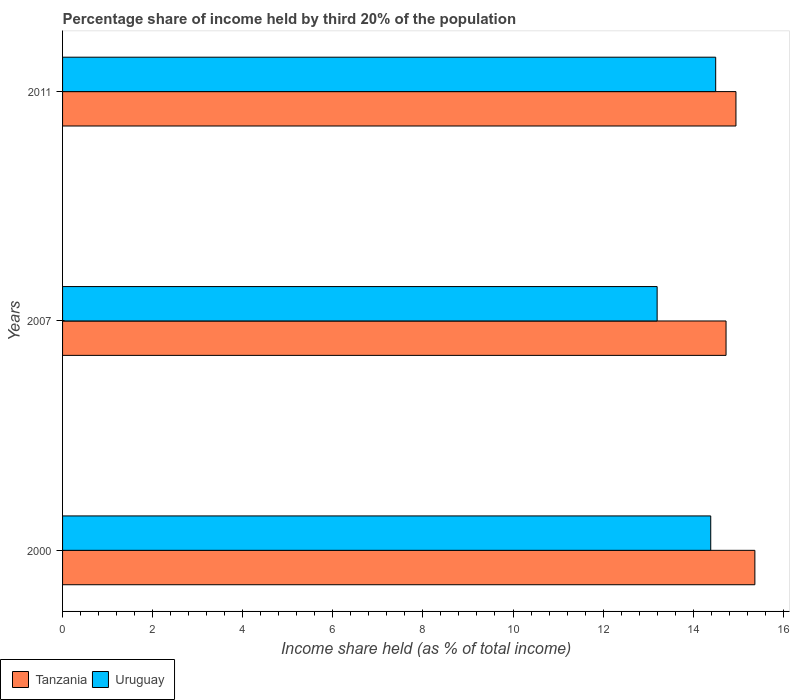How many different coloured bars are there?
Make the answer very short. 2. Are the number of bars per tick equal to the number of legend labels?
Your answer should be very brief. Yes. In how many cases, is the number of bars for a given year not equal to the number of legend labels?
Make the answer very short. 0. Across all years, what is the maximum share of income held by third 20% of the population in Uruguay?
Ensure brevity in your answer.  14.5. Across all years, what is the minimum share of income held by third 20% of the population in Tanzania?
Give a very brief answer. 14.73. In which year was the share of income held by third 20% of the population in Tanzania minimum?
Make the answer very short. 2007. What is the total share of income held by third 20% of the population in Uruguay in the graph?
Your response must be concise. 42.09. What is the difference between the share of income held by third 20% of the population in Uruguay in 2007 and that in 2011?
Make the answer very short. -1.3. What is the difference between the share of income held by third 20% of the population in Tanzania in 2000 and the share of income held by third 20% of the population in Uruguay in 2011?
Your answer should be compact. 0.87. What is the average share of income held by third 20% of the population in Tanzania per year?
Your answer should be compact. 15.02. In the year 2011, what is the difference between the share of income held by third 20% of the population in Uruguay and share of income held by third 20% of the population in Tanzania?
Your answer should be compact. -0.45. What is the ratio of the share of income held by third 20% of the population in Uruguay in 2000 to that in 2011?
Your answer should be very brief. 0.99. What is the difference between the highest and the second highest share of income held by third 20% of the population in Tanzania?
Your response must be concise. 0.42. What is the difference between the highest and the lowest share of income held by third 20% of the population in Uruguay?
Provide a short and direct response. 1.3. Is the sum of the share of income held by third 20% of the population in Uruguay in 2000 and 2007 greater than the maximum share of income held by third 20% of the population in Tanzania across all years?
Offer a terse response. Yes. What does the 2nd bar from the top in 2007 represents?
Provide a succinct answer. Tanzania. What does the 1st bar from the bottom in 2007 represents?
Give a very brief answer. Tanzania. How many bars are there?
Provide a short and direct response. 6. Are all the bars in the graph horizontal?
Offer a terse response. Yes. What is the difference between two consecutive major ticks on the X-axis?
Your answer should be very brief. 2. Are the values on the major ticks of X-axis written in scientific E-notation?
Your response must be concise. No. Does the graph contain any zero values?
Your response must be concise. No. Does the graph contain grids?
Your answer should be compact. No. How many legend labels are there?
Your response must be concise. 2. How are the legend labels stacked?
Your answer should be very brief. Horizontal. What is the title of the graph?
Your answer should be compact. Percentage share of income held by third 20% of the population. What is the label or title of the X-axis?
Ensure brevity in your answer.  Income share held (as % of total income). What is the Income share held (as % of total income) in Tanzania in 2000?
Provide a succinct answer. 15.37. What is the Income share held (as % of total income) in Uruguay in 2000?
Offer a terse response. 14.39. What is the Income share held (as % of total income) in Tanzania in 2007?
Give a very brief answer. 14.73. What is the Income share held (as % of total income) of Tanzania in 2011?
Offer a very short reply. 14.95. What is the Income share held (as % of total income) in Uruguay in 2011?
Your answer should be very brief. 14.5. Across all years, what is the maximum Income share held (as % of total income) in Tanzania?
Offer a terse response. 15.37. Across all years, what is the maximum Income share held (as % of total income) of Uruguay?
Provide a succinct answer. 14.5. Across all years, what is the minimum Income share held (as % of total income) in Tanzania?
Offer a terse response. 14.73. Across all years, what is the minimum Income share held (as % of total income) in Uruguay?
Keep it short and to the point. 13.2. What is the total Income share held (as % of total income) of Tanzania in the graph?
Keep it short and to the point. 45.05. What is the total Income share held (as % of total income) in Uruguay in the graph?
Provide a short and direct response. 42.09. What is the difference between the Income share held (as % of total income) of Tanzania in 2000 and that in 2007?
Make the answer very short. 0.64. What is the difference between the Income share held (as % of total income) in Uruguay in 2000 and that in 2007?
Your answer should be compact. 1.19. What is the difference between the Income share held (as % of total income) of Tanzania in 2000 and that in 2011?
Provide a short and direct response. 0.42. What is the difference between the Income share held (as % of total income) of Uruguay in 2000 and that in 2011?
Provide a short and direct response. -0.11. What is the difference between the Income share held (as % of total income) in Tanzania in 2007 and that in 2011?
Ensure brevity in your answer.  -0.22. What is the difference between the Income share held (as % of total income) in Uruguay in 2007 and that in 2011?
Your answer should be very brief. -1.3. What is the difference between the Income share held (as % of total income) in Tanzania in 2000 and the Income share held (as % of total income) in Uruguay in 2007?
Provide a succinct answer. 2.17. What is the difference between the Income share held (as % of total income) in Tanzania in 2000 and the Income share held (as % of total income) in Uruguay in 2011?
Provide a short and direct response. 0.87. What is the difference between the Income share held (as % of total income) in Tanzania in 2007 and the Income share held (as % of total income) in Uruguay in 2011?
Make the answer very short. 0.23. What is the average Income share held (as % of total income) in Tanzania per year?
Offer a terse response. 15.02. What is the average Income share held (as % of total income) of Uruguay per year?
Your response must be concise. 14.03. In the year 2000, what is the difference between the Income share held (as % of total income) in Tanzania and Income share held (as % of total income) in Uruguay?
Ensure brevity in your answer.  0.98. In the year 2007, what is the difference between the Income share held (as % of total income) of Tanzania and Income share held (as % of total income) of Uruguay?
Your answer should be very brief. 1.53. In the year 2011, what is the difference between the Income share held (as % of total income) in Tanzania and Income share held (as % of total income) in Uruguay?
Make the answer very short. 0.45. What is the ratio of the Income share held (as % of total income) in Tanzania in 2000 to that in 2007?
Give a very brief answer. 1.04. What is the ratio of the Income share held (as % of total income) in Uruguay in 2000 to that in 2007?
Your answer should be very brief. 1.09. What is the ratio of the Income share held (as % of total income) in Tanzania in 2000 to that in 2011?
Provide a short and direct response. 1.03. What is the ratio of the Income share held (as % of total income) in Tanzania in 2007 to that in 2011?
Provide a short and direct response. 0.99. What is the ratio of the Income share held (as % of total income) of Uruguay in 2007 to that in 2011?
Provide a short and direct response. 0.91. What is the difference between the highest and the second highest Income share held (as % of total income) in Tanzania?
Your answer should be compact. 0.42. What is the difference between the highest and the second highest Income share held (as % of total income) of Uruguay?
Offer a very short reply. 0.11. What is the difference between the highest and the lowest Income share held (as % of total income) of Tanzania?
Make the answer very short. 0.64. What is the difference between the highest and the lowest Income share held (as % of total income) in Uruguay?
Ensure brevity in your answer.  1.3. 